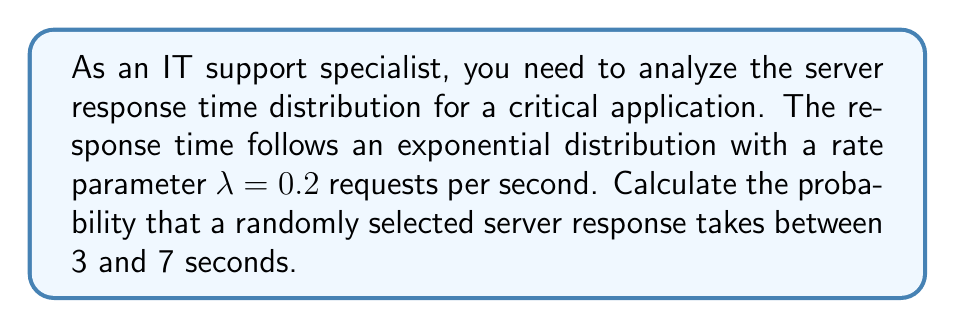Provide a solution to this math problem. To solve this problem, we'll use the probability density function (PDF) of the exponential distribution and integrate it over the given interval.

1. The PDF of the exponential distribution is given by:
   $$f(t) = \lambda e^{-\lambda t}, \quad t \geq 0$$

2. We need to calculate:
   $$P(3 \leq T \leq 7) = \int_{3}^{7} f(t) dt$$

3. Substituting the given $\lambda = 0.2$ and integrating:
   $$\begin{align}
   P(3 \leq T \leq 7) &= \int_{3}^{7} 0.2 e^{-0.2t} dt \\
   &= -e^{-0.2t} \Big|_{3}^{7} \\
   &= -e^{-0.2 \cdot 7} - (-e^{-0.2 \cdot 3}) \\
   &= e^{-0.6} - e^{-1.4}
   \end{align}$$

4. Evaluating the exponentials:
   $$\begin{align}
   P(3 \leq T \leq 7) &= e^{-0.6} - e^{-1.4} \\
   &\approx 0.5488 - 0.2466 \\
   &\approx 0.3022
   \end{align}$$

Therefore, the probability that a randomly selected server response takes between 3 and 7 seconds is approximately 0.3022 or 30.22%.
Answer: 0.3022 (or 30.22%) 